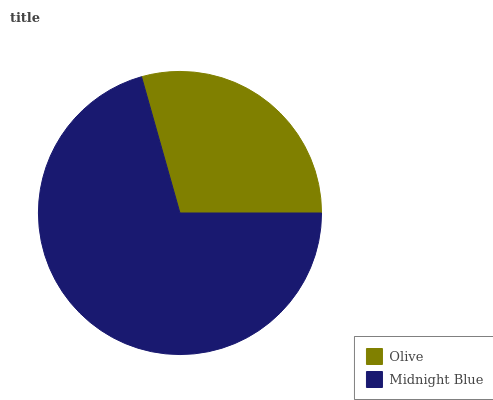Is Olive the minimum?
Answer yes or no. Yes. Is Midnight Blue the maximum?
Answer yes or no. Yes. Is Midnight Blue the minimum?
Answer yes or no. No. Is Midnight Blue greater than Olive?
Answer yes or no. Yes. Is Olive less than Midnight Blue?
Answer yes or no. Yes. Is Olive greater than Midnight Blue?
Answer yes or no. No. Is Midnight Blue less than Olive?
Answer yes or no. No. Is Midnight Blue the high median?
Answer yes or no. Yes. Is Olive the low median?
Answer yes or no. Yes. Is Olive the high median?
Answer yes or no. No. Is Midnight Blue the low median?
Answer yes or no. No. 